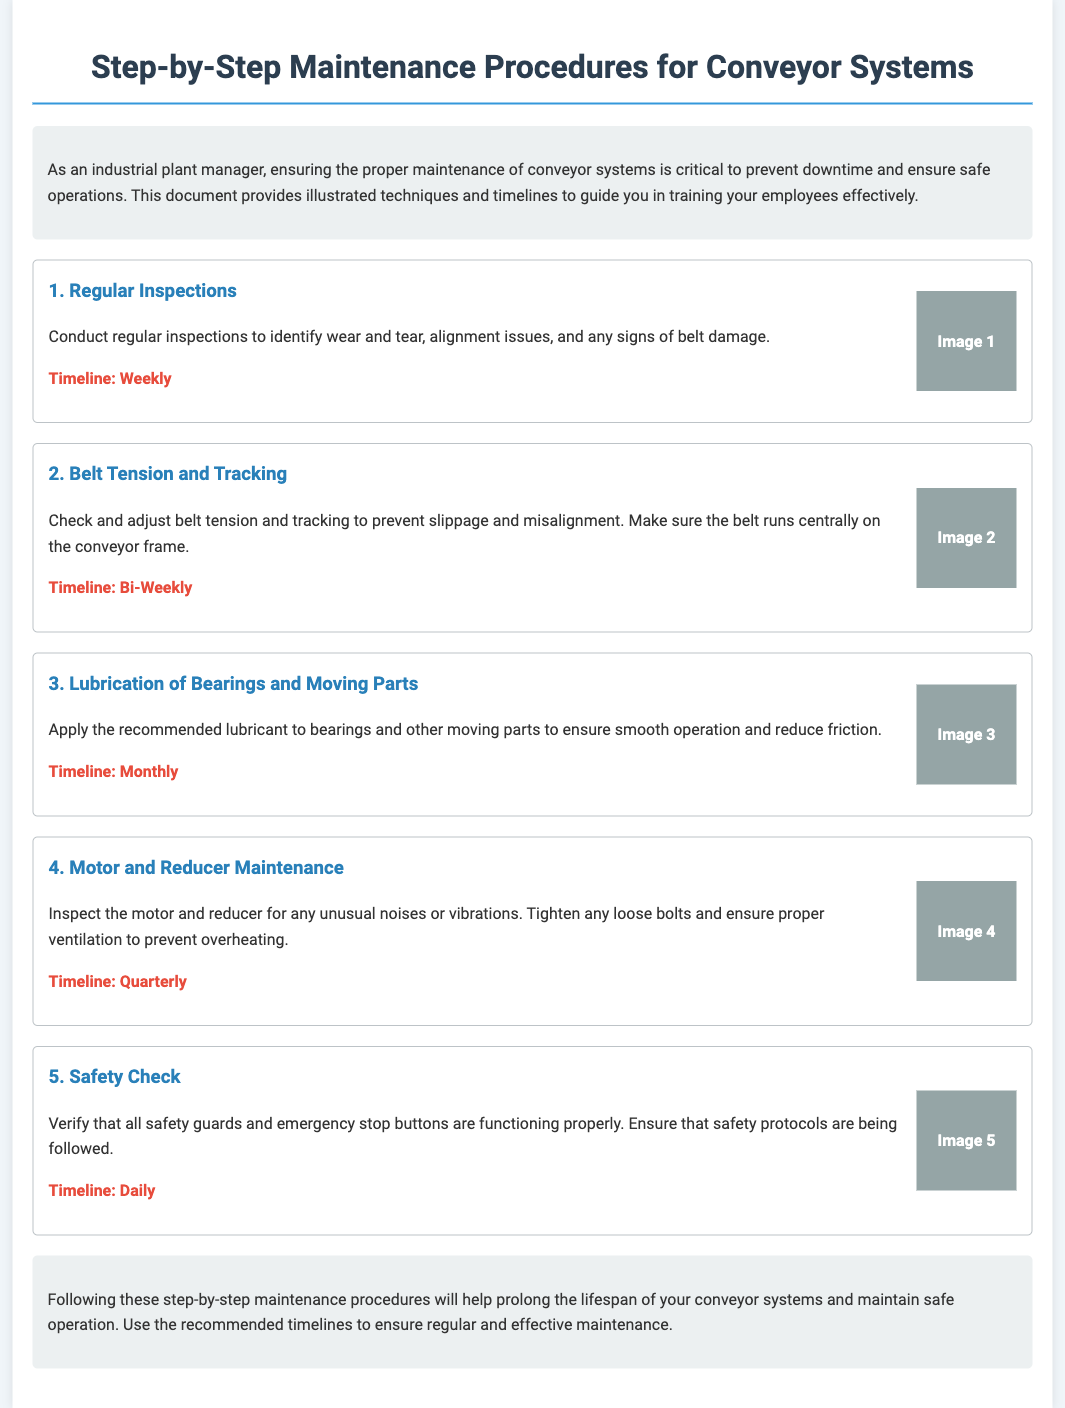what is the title of the document? The title appears at the top of the document, highlighting the subject of the maintenance procedures.
Answer: Step-by-Step Maintenance Procedures for Conveyor Systems how often should regular inspections be conducted? The frequency for regular inspections is stated in the timelines section of the document.
Answer: Weekly what is the timeline for lubrication of bearings and moving parts? The timeline for lubrication is specified in the maintenance procedures section for that step.
Answer: Monthly what should be inspected during motor and reducer maintenance? The document mentions the key aspects that need inspection in this maintenance step.
Answer: Noises and vibrations how frequently should safety checks be performed? The document provides a specific frequency for safety checks in the timeline section.
Answer: Daily what technique is recommended for checking belt tension? The document gives a specific procedure for belt tension in the relevant maintenance section.
Answer: Adjusting which step involves tightening loose bolts? The document includes details on which maintenance step relates to tightening.
Answer: Motor and Reducer Maintenance what is the purpose of applying lubricant according to the document? The document outlines the main reason for applying lubricant in its specific maintenance section.
Answer: Reduce friction how many main maintenance steps are outlined in the document? The document lists the number of maintenance steps in the procedural layout.
Answer: Five 